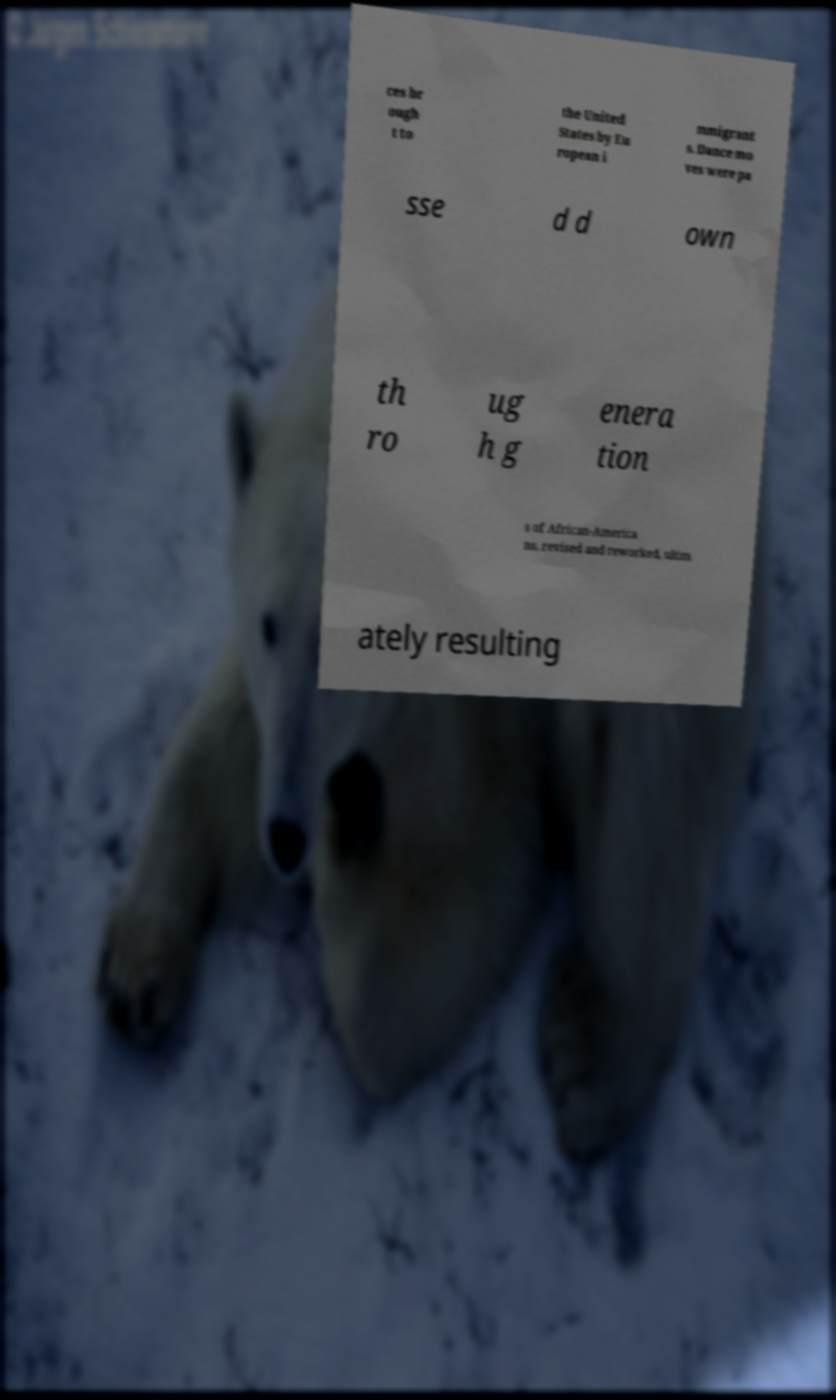Could you assist in decoding the text presented in this image and type it out clearly? ces br ough t to the United States by Eu ropean i mmigrant s. Dance mo ves were pa sse d d own th ro ug h g enera tion s of African-America ns, revised and reworked, ultim ately resulting 